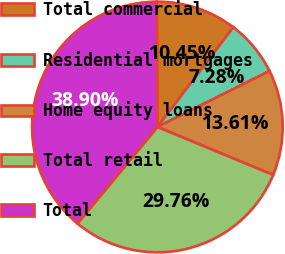Convert chart to OTSL. <chart><loc_0><loc_0><loc_500><loc_500><pie_chart><fcel>Total commercial<fcel>Residential mortgages<fcel>Home equity loans<fcel>Total retail<fcel>Total<nl><fcel>10.45%<fcel>7.28%<fcel>13.61%<fcel>29.76%<fcel>38.9%<nl></chart> 